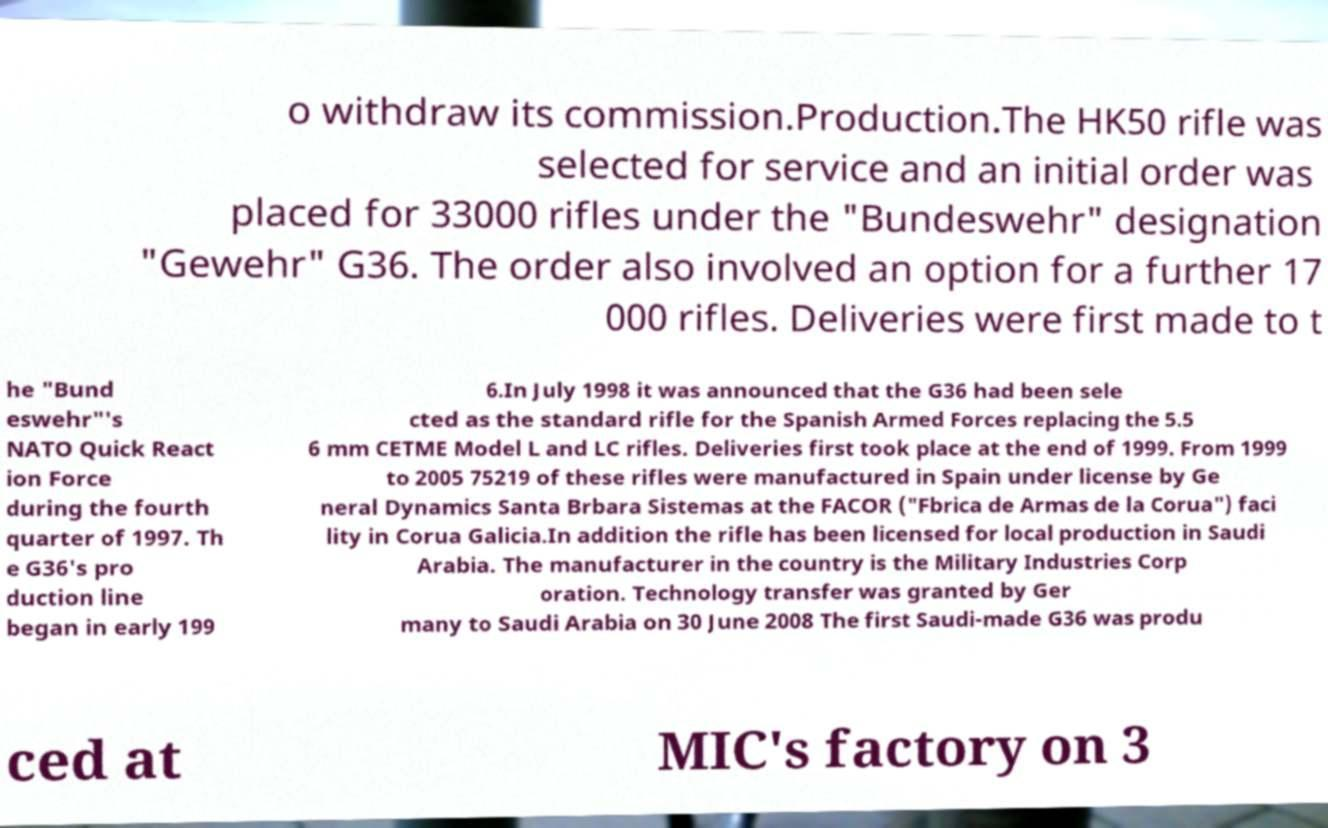Could you extract and type out the text from this image? o withdraw its commission.Production.The HK50 rifle was selected for service and an initial order was placed for 33000 rifles under the "Bundeswehr" designation "Gewehr" G36. The order also involved an option for a further 17 000 rifles. Deliveries were first made to t he "Bund eswehr"'s NATO Quick React ion Force during the fourth quarter of 1997. Th e G36's pro duction line began in early 199 6.In July 1998 it was announced that the G36 had been sele cted as the standard rifle for the Spanish Armed Forces replacing the 5.5 6 mm CETME Model L and LC rifles. Deliveries first took place at the end of 1999. From 1999 to 2005 75219 of these rifles were manufactured in Spain under license by Ge neral Dynamics Santa Brbara Sistemas at the FACOR ("Fbrica de Armas de la Corua") faci lity in Corua Galicia.In addition the rifle has been licensed for local production in Saudi Arabia. The manufacturer in the country is the Military Industries Corp oration. Technology transfer was granted by Ger many to Saudi Arabia on 30 June 2008 The first Saudi-made G36 was produ ced at MIC's factory on 3 